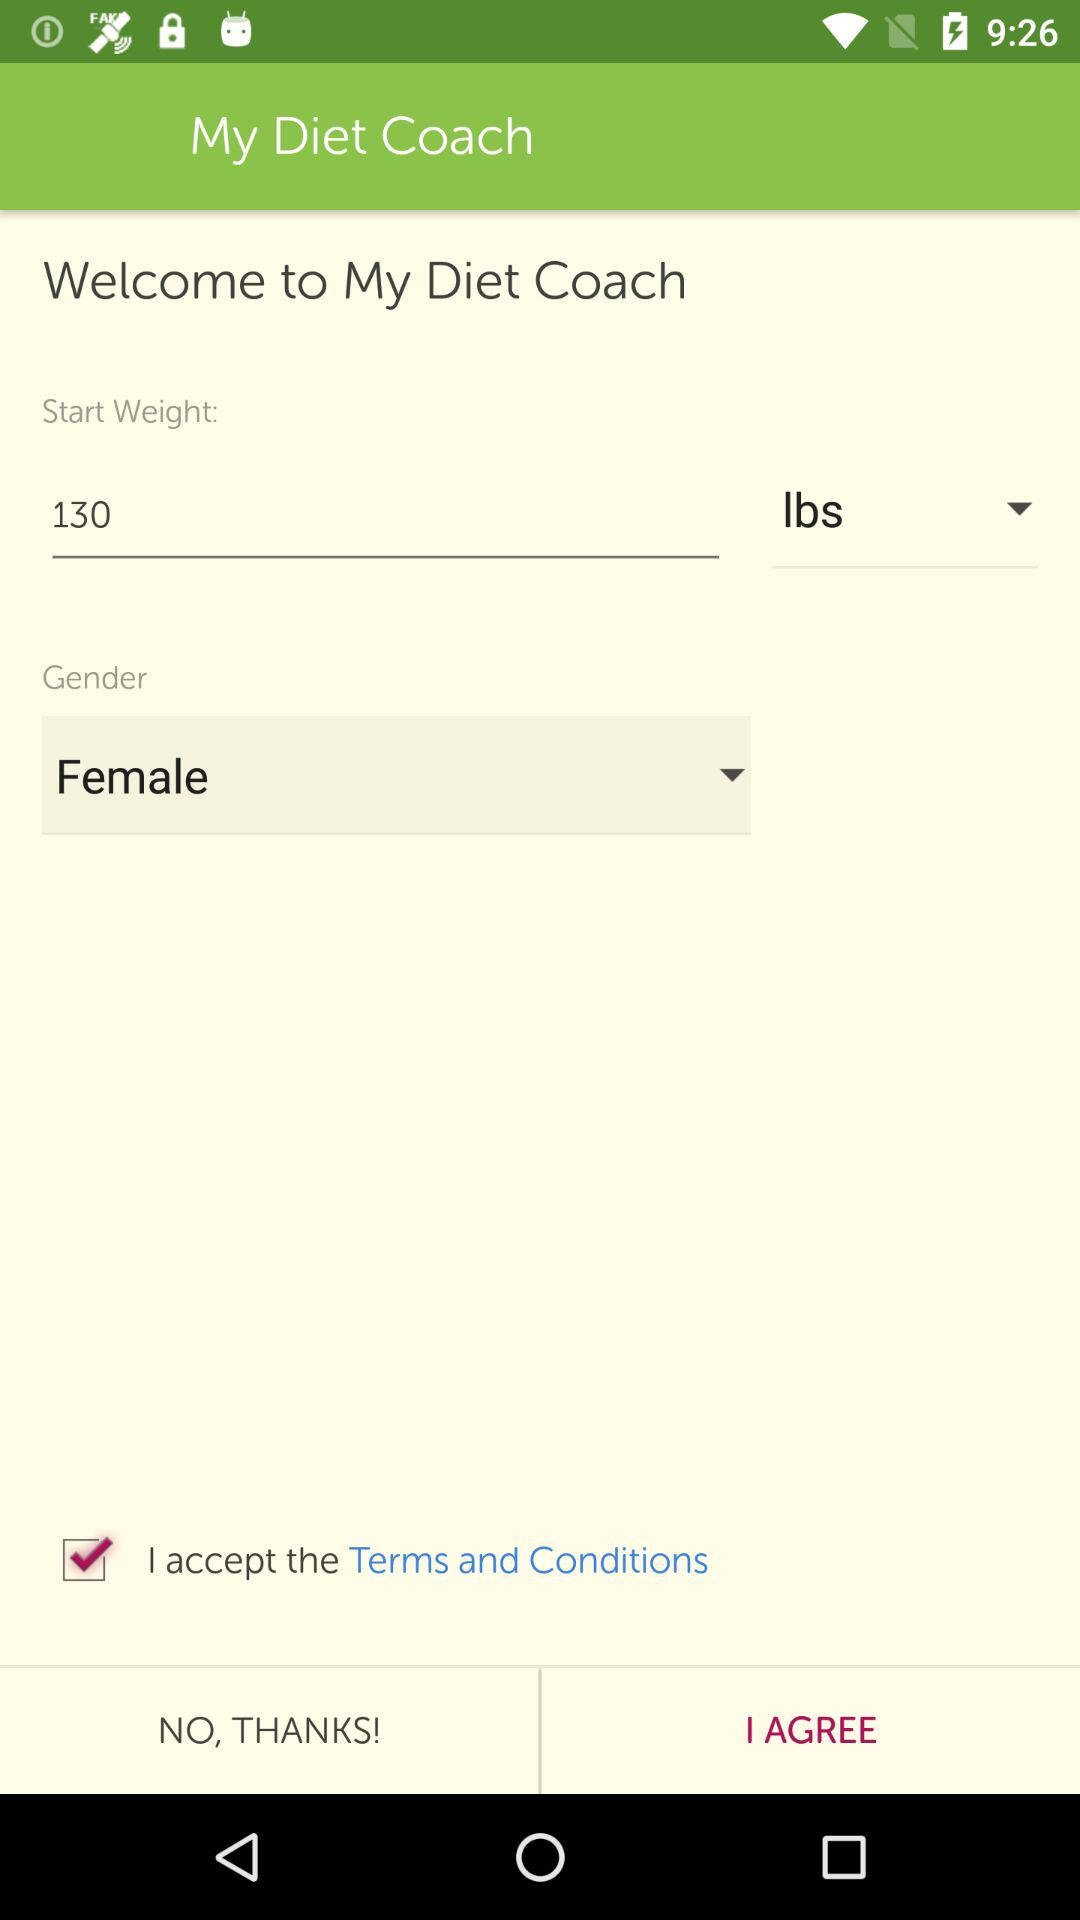What is the gender of the user? The gender is female. 